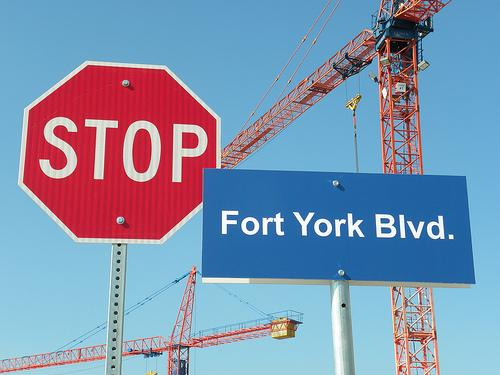Count the number of bolts attaching the blue sign and red stop sign to their respective poles. There are four bolts in total, two for each sign. Analyze the purpose of the red sign and describe its design elements. The red sign is a stop sign with white lettering and a white border, intended to instruct drivers to halt at the designated area. What type of sign is placed beside the blue street sign? A red stop sign is placed beside the blue street sign. Describe the interaction between the signs and the crane in the image. The crane is in the background behind the blue street sign and red stop sign, which are in the foreground. Express the sentiment evoked by the presence of the stop sign and crane. The image with the stop sign and crane feels industrial and orderly. What are the main colors of the crane in the background? The main colors of the crane are orange and red. How many total signs are visible in the image? Two signs are visible in the image. What shape is the red sign? The red sign is an octagon. Identify the phrase written on the blue street sign. Fort York Blvd. Assess the visibility and clarity of the text on the blue street sign. The white text on the blue street sign is visible and clear. Is there an orange bucket on the left side of the blue crane? The orange bucket is on the side of the red crane, not the blue one. Does the red sign say "stop" or "yield"? Stop Is the word "stop" written in blue letters on the red sign? The "stop" word on the red sign is written with white letters, not blue. Explain the various elements present in the street signs. The image contains a blue street sign with white text "Fort York Blvd." and a red stop sign with white text. Both signs are attached to poles and fastened with bolts. Is there a yellow pulley above the stop sign? The yellow pulley is underneath the crane, not above the stop sign. Is there a construction-related event occurring in the background? Yes, there are cranes in the background which suggest construction-related event. What words are visible on the blue street sign? Fort, York, Blvd Identify the action taking place in the image. There is no specific action taking place in the image. Is there any fastening equipment visible in the image? Yes, there are bolts or rivets holding the signs to the poles. Describe the appearance of the blue street sign in detail. The blue street sign is square-shaped with white text "Fort York Blvd" written on it. It has a gray and white edge and is attached to a silver pole by fasteners. The sign's dimensions are approximately 268x268. Determine if there is a traffic-related activity happening in the image. There is no traffic-related activity occurring in the image. Are the cables on the crane green in color? No, it's not mentioned in the image. Is the blue street sign attached to a wooden pole? The blue street sign is attached to a silver-colored pole, not a wooden one. Is there a round-shaped red sign in the image? The red sign in the image is octagon-shaped, not round. Which words are on the blue sign: "Fort St. Blvd" or "Fort York Blvd"? Fort York Blvd Create a public service announcement based on the information from the image. Attention drivers: Please be aware of construction in the Fort York Blvd. area. Make sure to obey traffic rules including following stop signs for the safety of everyone. Create a short narrative about a character's interaction with the signs in the image. As Jane approached the intersection, she noticed the blue street sign that read "Fort York Blvd." and made a mental note of her location. A red stop sign demanded her attention, so she firmly pressed the brake pedal and patiently waited for her turn to proceed. Give a detailed description of the stop sign in the picture. The stop sign is red and octagon-shaped with white text and border. It is fastened to a pole with two bolts and has dimensions of approximately 202x202. Write a haiku describing the image. Steel giants loom tall State whether the crane in the image is red or orange. The crane is orange-red. Describe the primary components and features of the scene in a poetic way. Amidst a concrete jungle, a sign of azure hue stands proud, with its words "Fort York Blvd." inscribed in white, as the towers of mechanical cranes loom behind, and a vigilant red sentinel whispers an order to "stop". 